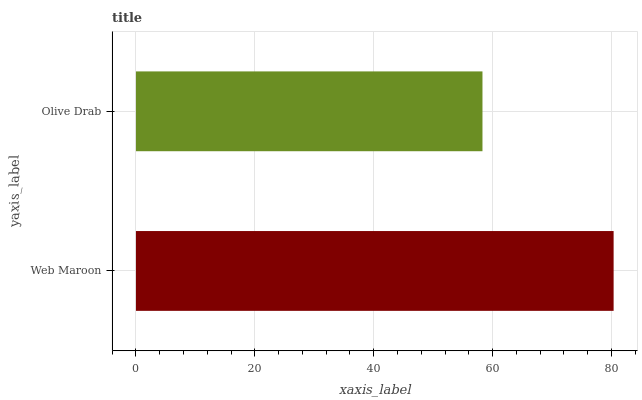Is Olive Drab the minimum?
Answer yes or no. Yes. Is Web Maroon the maximum?
Answer yes or no. Yes. Is Olive Drab the maximum?
Answer yes or no. No. Is Web Maroon greater than Olive Drab?
Answer yes or no. Yes. Is Olive Drab less than Web Maroon?
Answer yes or no. Yes. Is Olive Drab greater than Web Maroon?
Answer yes or no. No. Is Web Maroon less than Olive Drab?
Answer yes or no. No. Is Web Maroon the high median?
Answer yes or no. Yes. Is Olive Drab the low median?
Answer yes or no. Yes. Is Olive Drab the high median?
Answer yes or no. No. Is Web Maroon the low median?
Answer yes or no. No. 